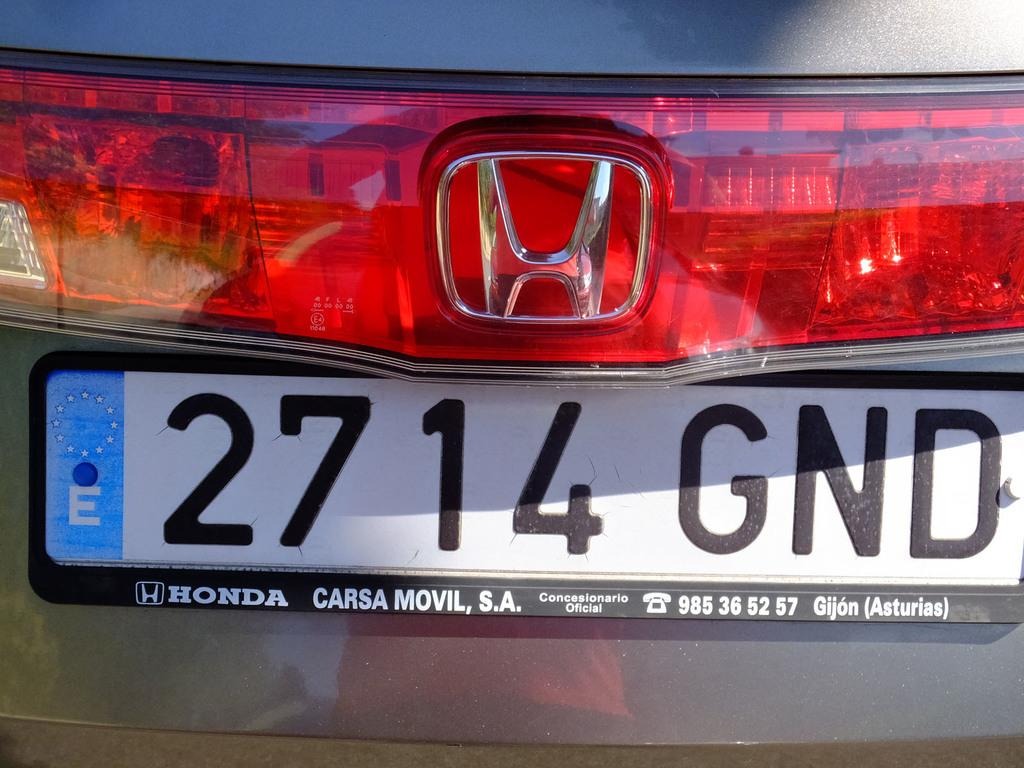<image>
Summarize the visual content of the image. A Honda has a license plate that reads 2714 GND. 